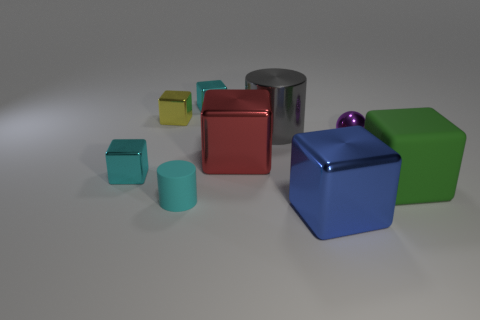Subtract all yellow cubes. How many cubes are left? 5 Subtract all cyan cubes. How many cubes are left? 4 Add 1 large yellow shiny cylinders. How many objects exist? 10 Subtract 2 cylinders. How many cylinders are left? 0 Subtract all balls. How many objects are left? 8 Subtract all yellow cylinders. How many cyan cubes are left? 2 Subtract all cyan rubber cylinders. Subtract all metal spheres. How many objects are left? 7 Add 6 cylinders. How many cylinders are left? 8 Add 6 small purple matte balls. How many small purple matte balls exist? 6 Subtract 0 brown cylinders. How many objects are left? 9 